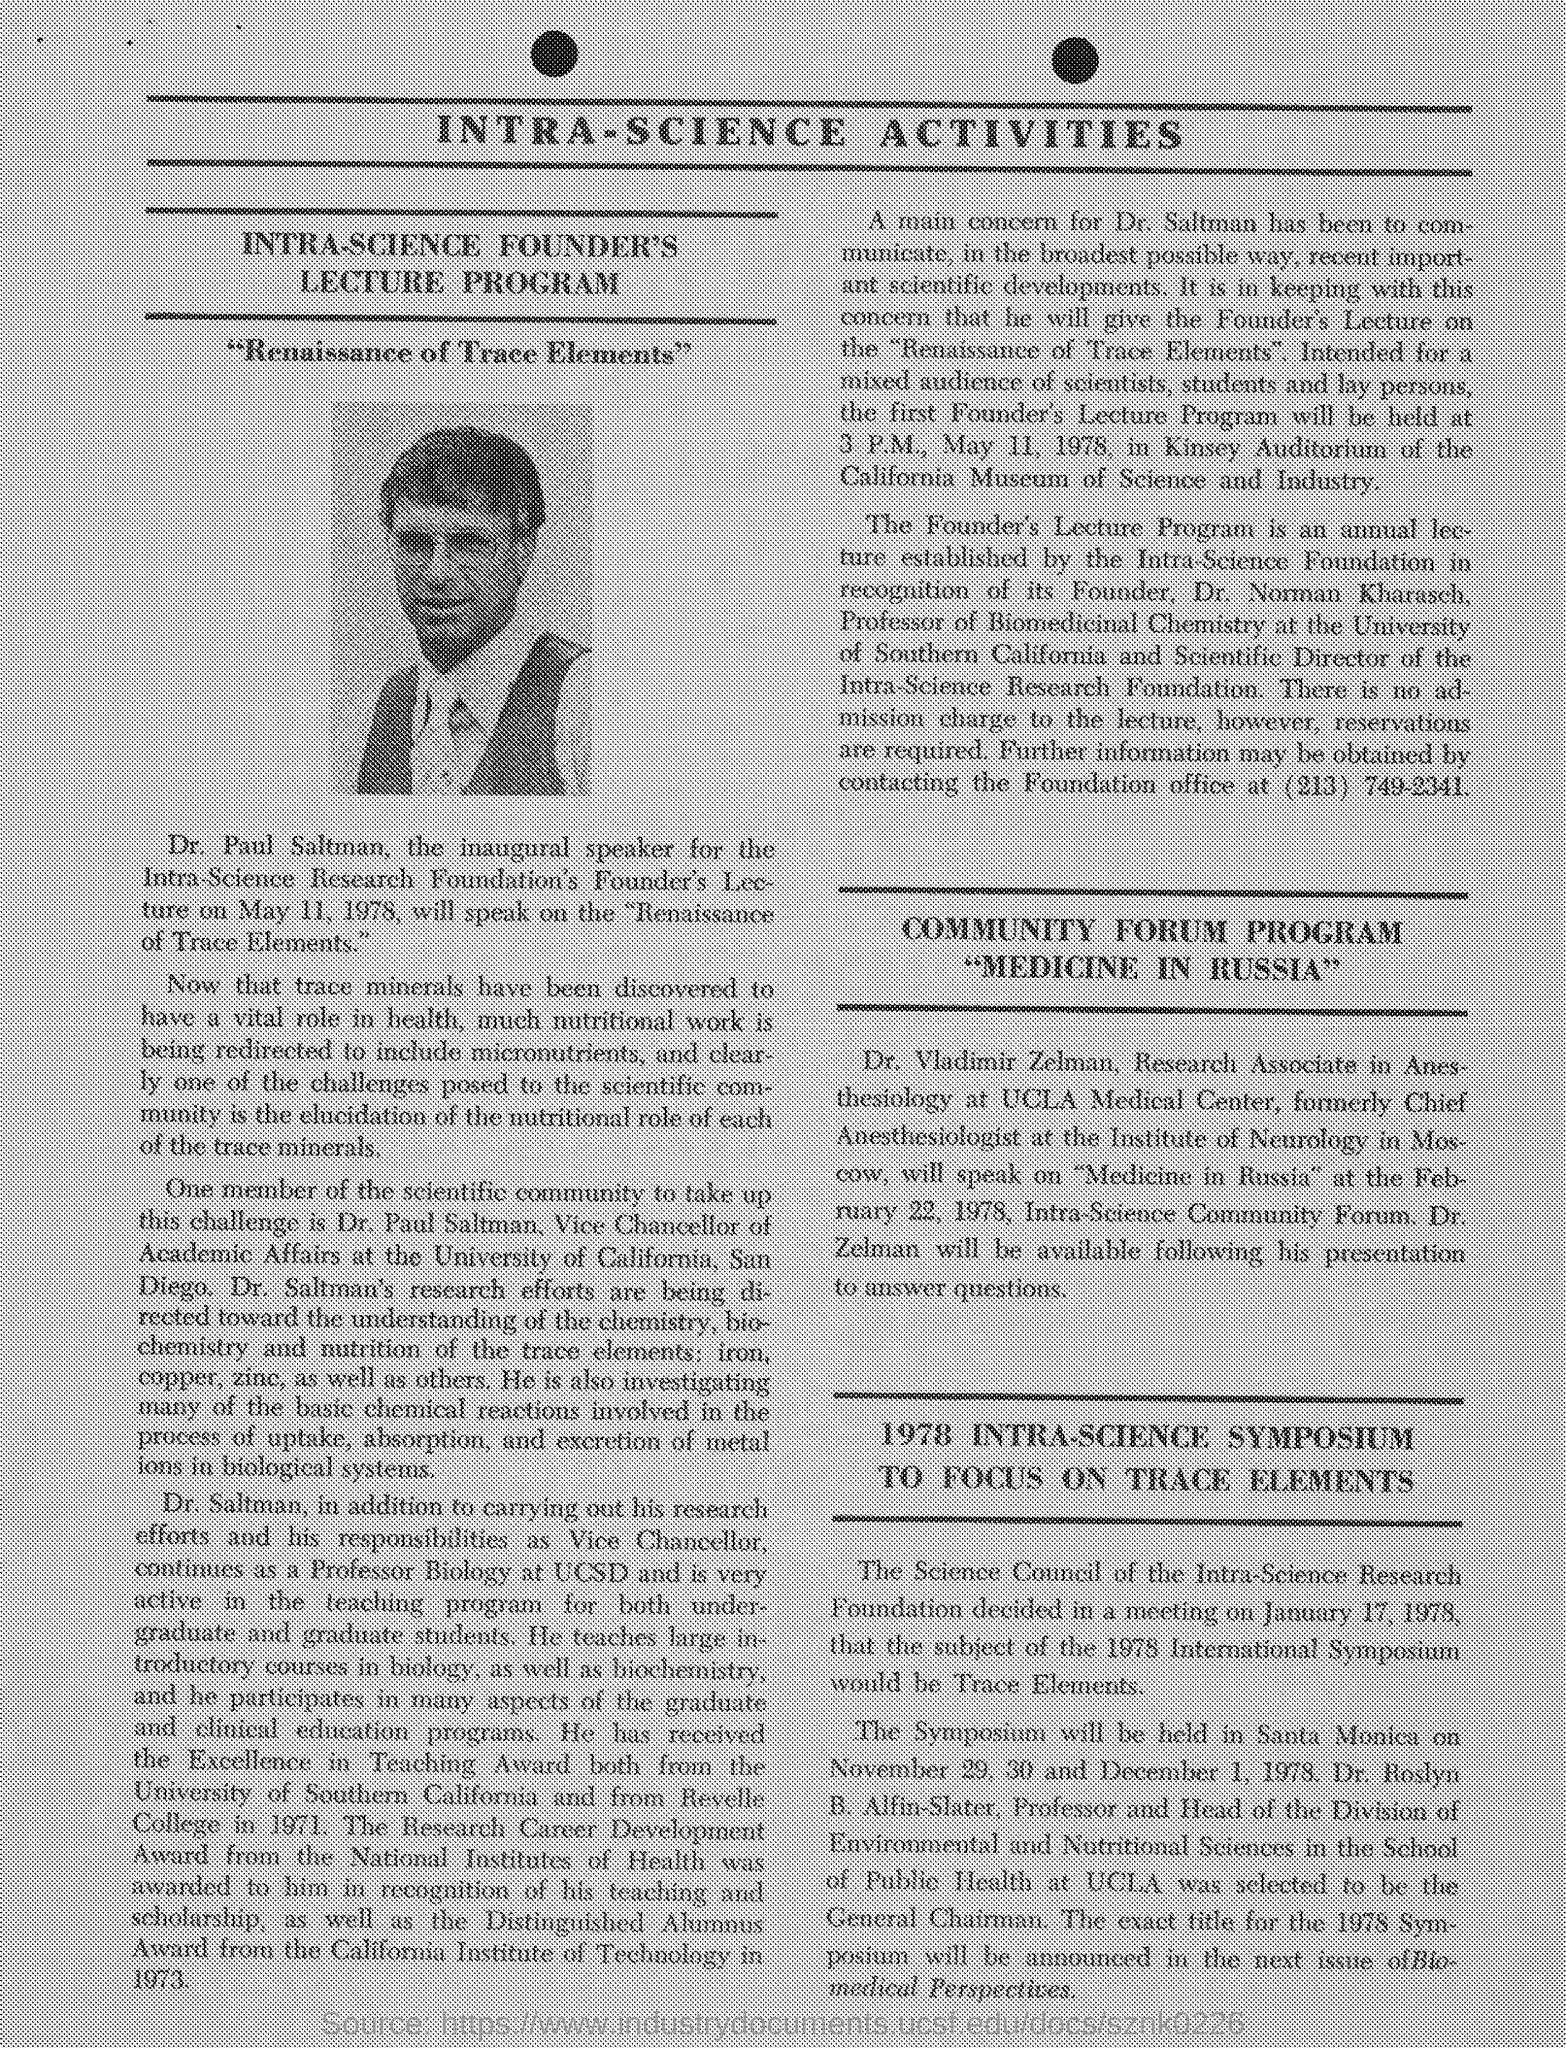Who is the inaugural speaker ?
Make the answer very short. Dr. Paul Saltman. On which topic,  will Dr Paul Saltman will speak ?
Your answer should be very brief. "Renaissance of Trace Elements". What is written just above the picture?
Your response must be concise. "Renaissance of Trace Elements". Who's picture is shown in the document ?
Make the answer very short. Dr. Saltman. Where is the symposium is held ?
Provide a succinct answer. Santa Monica. Who is the founder of ''Intra-science foundation'' ?
Your answer should be compact. Dr. Norman Kharasch. 